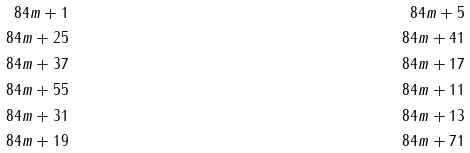Convert formula to latex. <formula><loc_0><loc_0><loc_500><loc_500>8 4 m + 1 & & 8 4 m + 5 \\ 8 4 m + 2 5 & & 8 4 m + 4 1 \\ 8 4 m + 3 7 & & 8 4 m + 1 7 \\ 8 4 m + 5 5 & & 8 4 m + 1 1 \\ 8 4 m + 3 1 & & 8 4 m + 1 3 \\ 8 4 m + 1 9 & & 8 4 m + 7 1</formula> 